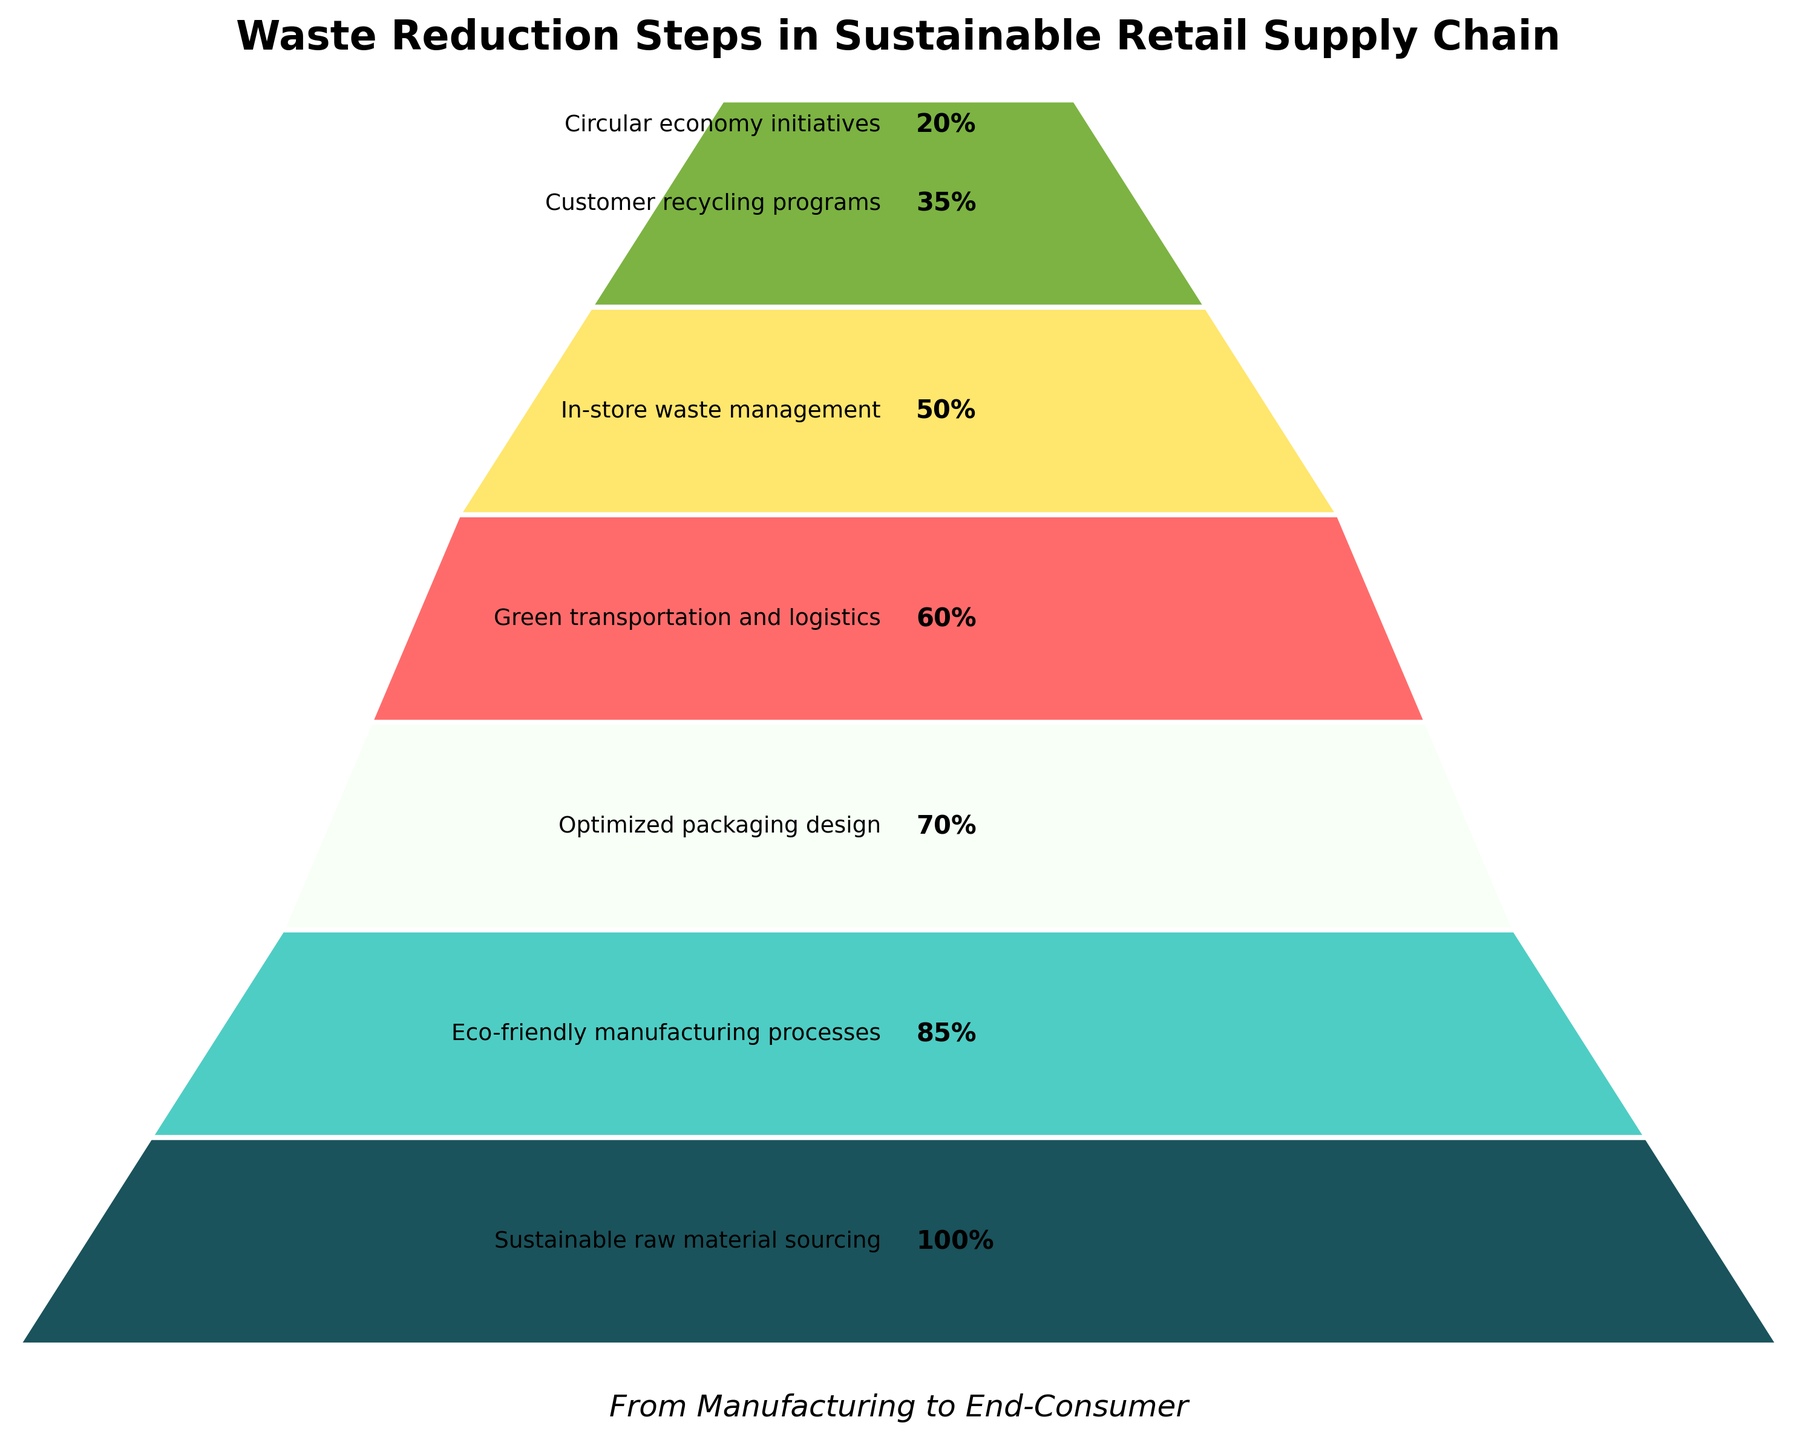What's the title of the figure? The title is shown at the top of the figure, which reads "Waste Reduction Steps in Sustainable Retail Supply Chain".
Answer: Waste Reduction Steps in Sustainable Retail Supply Chain Which step has the highest percentage? The step with the highest percentage is listed at the top of the funnel and is marked as 100%. This corresponds to "Sustainable raw material sourcing".
Answer: Sustainable raw material sourcing What's the percentage difference between Eco-friendly manufacturing processes and Green transportation and logistics? Eco-friendly manufacturing processes are 85%, and Green transportation and logistics are 60%. The difference is 85% - 60% = 25%.
Answer: 25% Which step marks the transition below half of the total percentage? The step that marks the transition below half is the first step below 50%, which is "Customer recycling programs" at 35%.
Answer: Customer recycling programs (35%) What is the color of the segment representing the Circular economy initiatives? The Circular economy initiatives segment is at the bottom of the funnel, and it is shown in the final color from the custom color palette, which is likely green.
Answer: Green What is the total number of steps in the funnel chart? Count the distinct segments or steps listed from top to bottom in the funnel chart. There are seven steps in total.
Answer: 7 Compare the percentages of Eco-friendly manufacturing processes and Optimized packaging design. Which one is greater and by how much? Eco-friendly manufacturing processes are at 85%, and Optimized packaging design is at 70%. The difference is 85% - 70% = 15%. Therefore, Eco-friendly manufacturing processes are greater by 15%.
Answer: Eco-friendly manufacturing processes, 15% What is the average percentage of the steps listed in the funnel chart? Add all percentages together and divide by the number of steps. (100 + 85 + 70 + 60 + 50 + 35 + 20) / 7 = 420 / 7 = 60%.
Answer: 60% Is the percentage of In-store waste management greater than or equal to 60%? The percentage of In-store waste management is 50%, which is less than 60%.
Answer: No Looking at the funnel's last two steps, what is their combined percentage? The last two steps are Customer recycling programs (35%) and Circular economy initiatives (20%). Their combined percentage is 35% + 20% = 55%.
Answer: 55% 